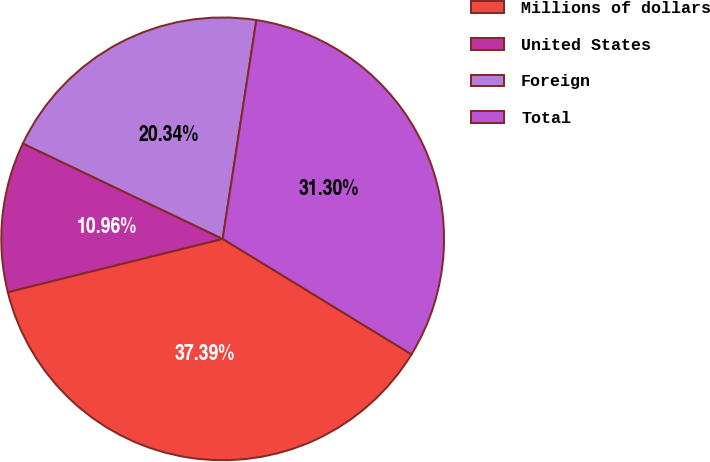Convert chart. <chart><loc_0><loc_0><loc_500><loc_500><pie_chart><fcel>Millions of dollars<fcel>United States<fcel>Foreign<fcel>Total<nl><fcel>37.39%<fcel>10.96%<fcel>20.34%<fcel>31.3%<nl></chart> 